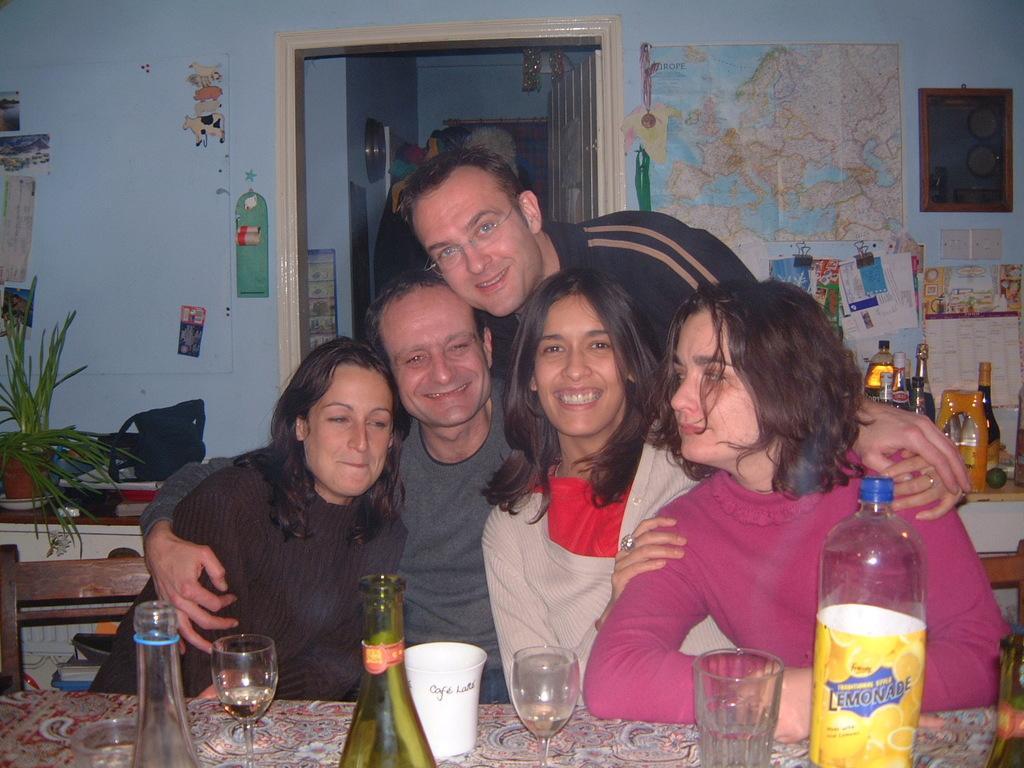Could you give a brief overview of what you see in this image? In this picture there are three women a man sitting on the chair. There is a man standing at back. There is a glass, bottle, cup on the table. There is a flower pot, plant, black handbag, book on the desk. There is a map and few bottles at the background. There are some stickers on the wall. There is a frame. 